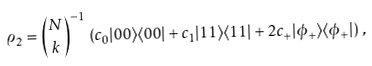Convert formula to latex. <formula><loc_0><loc_0><loc_500><loc_500>\varrho _ { 2 } = { N \choose k } ^ { - 1 } \, \left ( c _ { 0 } | 0 0 \rangle \langle 0 0 | + c _ { 1 } | 1 1 \rangle \langle 1 1 | + 2 c _ { + } | \phi _ { + } \rangle \langle \phi _ { + } | \right ) \, ,</formula> 